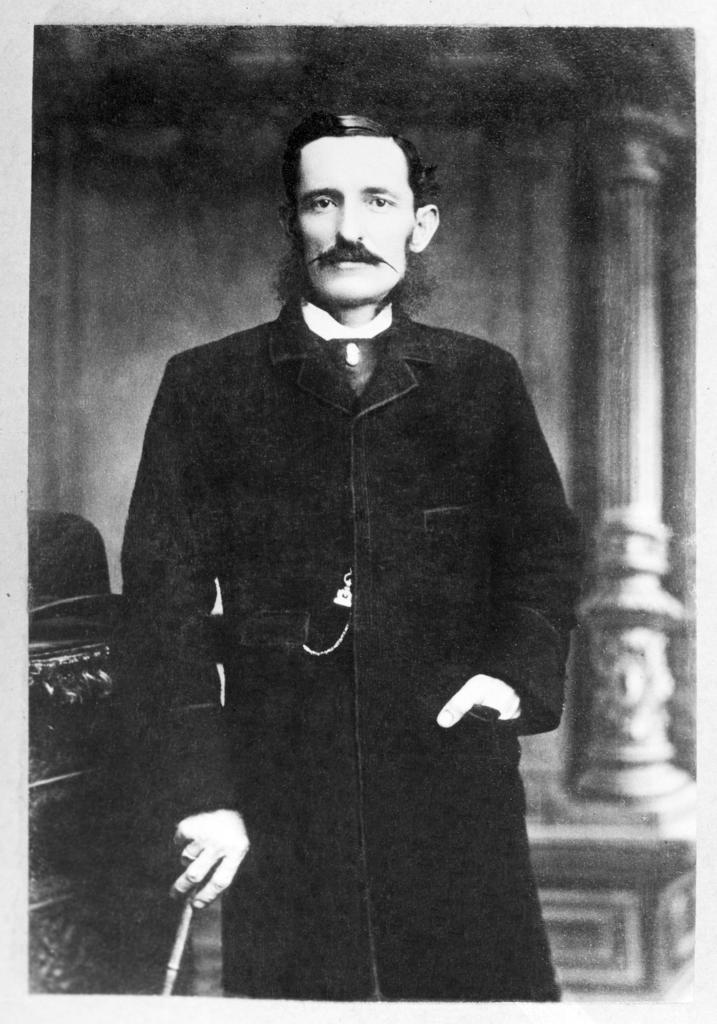Can you describe this image briefly? It is a black and white image there is a man standing beside an object and he is posing for the photo, there is a pillar behind the man. 